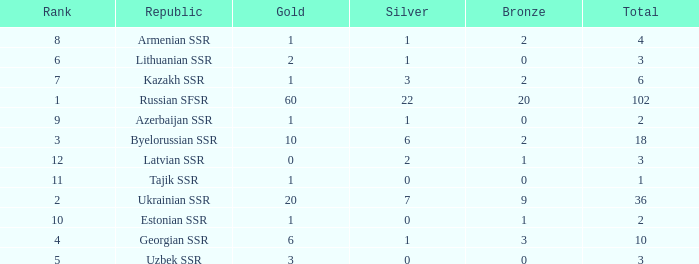What is the highest number of bronzes for teams ranked number 7 with more than 0 silver? 2.0. 